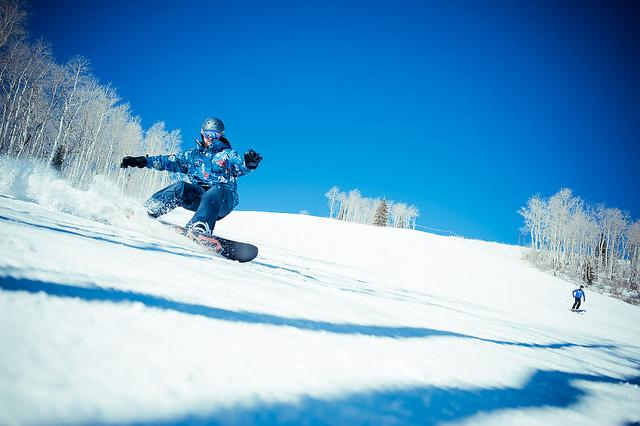In which direction is this snowboarder moving?

Choices:
A) left
B) away
C) towards
D) right right 